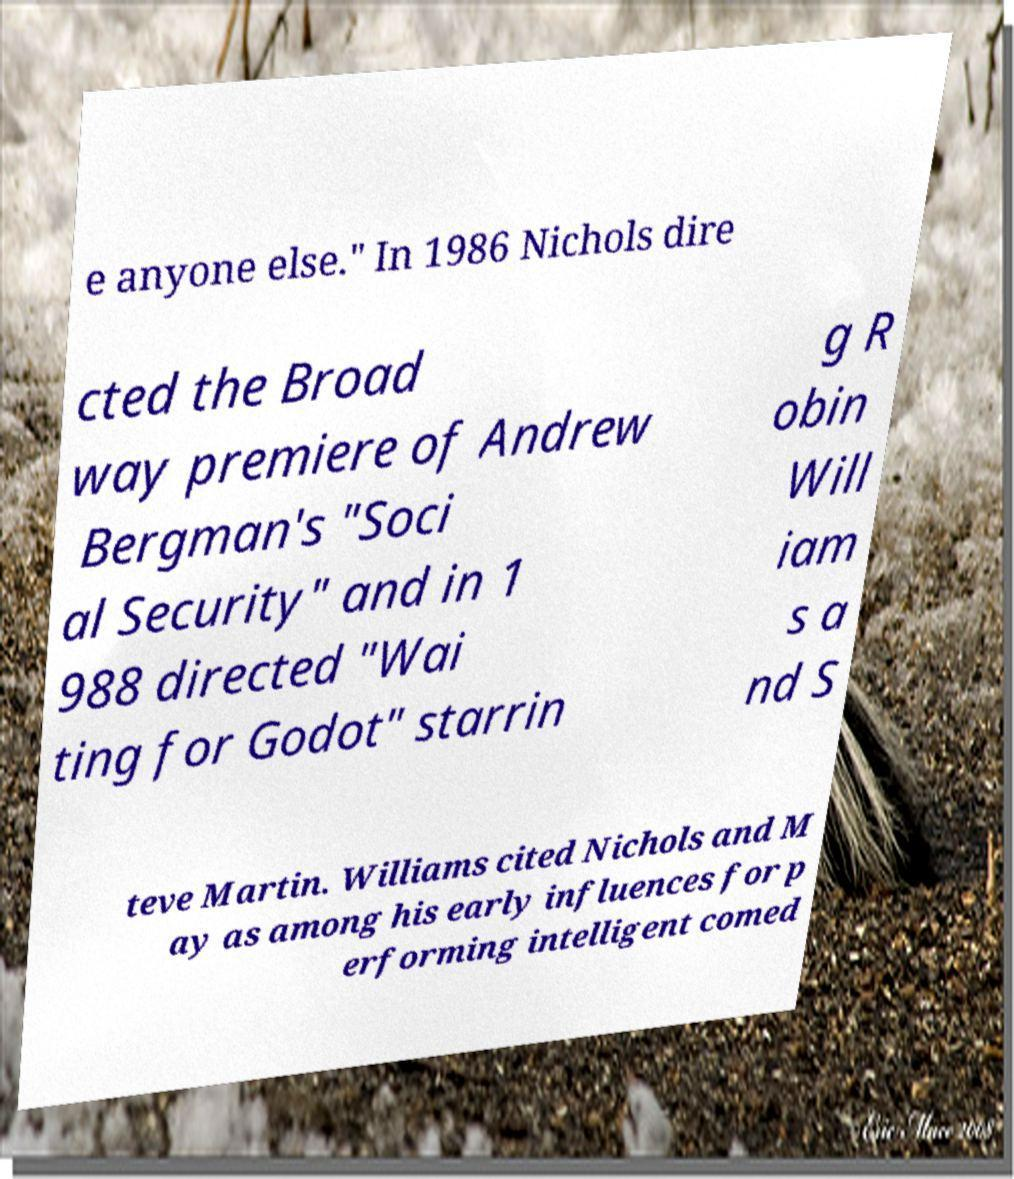There's text embedded in this image that I need extracted. Can you transcribe it verbatim? e anyone else." In 1986 Nichols dire cted the Broad way premiere of Andrew Bergman's "Soci al Security" and in 1 988 directed "Wai ting for Godot" starrin g R obin Will iam s a nd S teve Martin. Williams cited Nichols and M ay as among his early influences for p erforming intelligent comed 